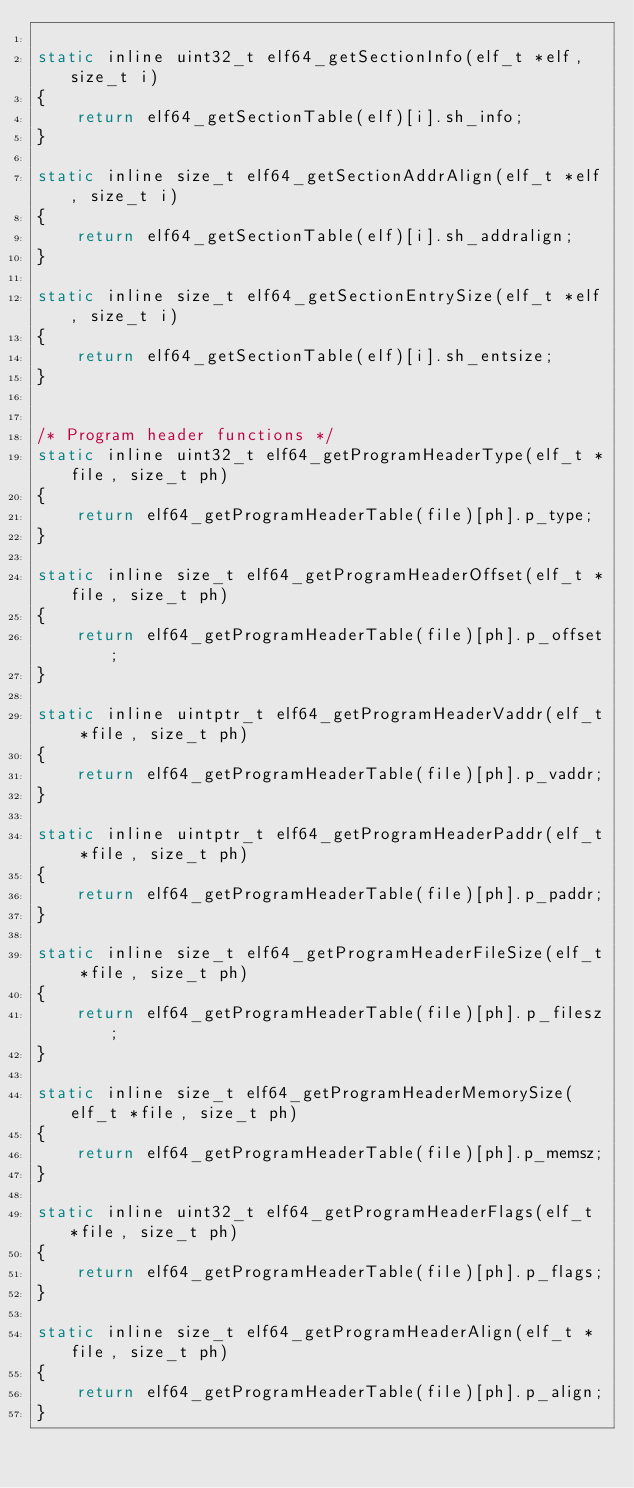<code> <loc_0><loc_0><loc_500><loc_500><_C_>
static inline uint32_t elf64_getSectionInfo(elf_t *elf, size_t i)
{
    return elf64_getSectionTable(elf)[i].sh_info;
}

static inline size_t elf64_getSectionAddrAlign(elf_t *elf, size_t i)
{
    return elf64_getSectionTable(elf)[i].sh_addralign;
}

static inline size_t elf64_getSectionEntrySize(elf_t *elf, size_t i)
{
    return elf64_getSectionTable(elf)[i].sh_entsize;
}


/* Program header functions */
static inline uint32_t elf64_getProgramHeaderType(elf_t *file, size_t ph)
{
    return elf64_getProgramHeaderTable(file)[ph].p_type;
}

static inline size_t elf64_getProgramHeaderOffset(elf_t *file, size_t ph)
{
    return elf64_getProgramHeaderTable(file)[ph].p_offset;
}

static inline uintptr_t elf64_getProgramHeaderVaddr(elf_t *file, size_t ph)
{
    return elf64_getProgramHeaderTable(file)[ph].p_vaddr;
}

static inline uintptr_t elf64_getProgramHeaderPaddr(elf_t *file, size_t ph)
{
    return elf64_getProgramHeaderTable(file)[ph].p_paddr;
}

static inline size_t elf64_getProgramHeaderFileSize(elf_t *file, size_t ph)
{
    return elf64_getProgramHeaderTable(file)[ph].p_filesz;
}

static inline size_t elf64_getProgramHeaderMemorySize(elf_t *file, size_t ph)
{
    return elf64_getProgramHeaderTable(file)[ph].p_memsz;
}

static inline uint32_t elf64_getProgramHeaderFlags(elf_t *file, size_t ph)
{
    return elf64_getProgramHeaderTable(file)[ph].p_flags;
}

static inline size_t elf64_getProgramHeaderAlign(elf_t *file, size_t ph)
{
    return elf64_getProgramHeaderTable(file)[ph].p_align;
}

</code> 